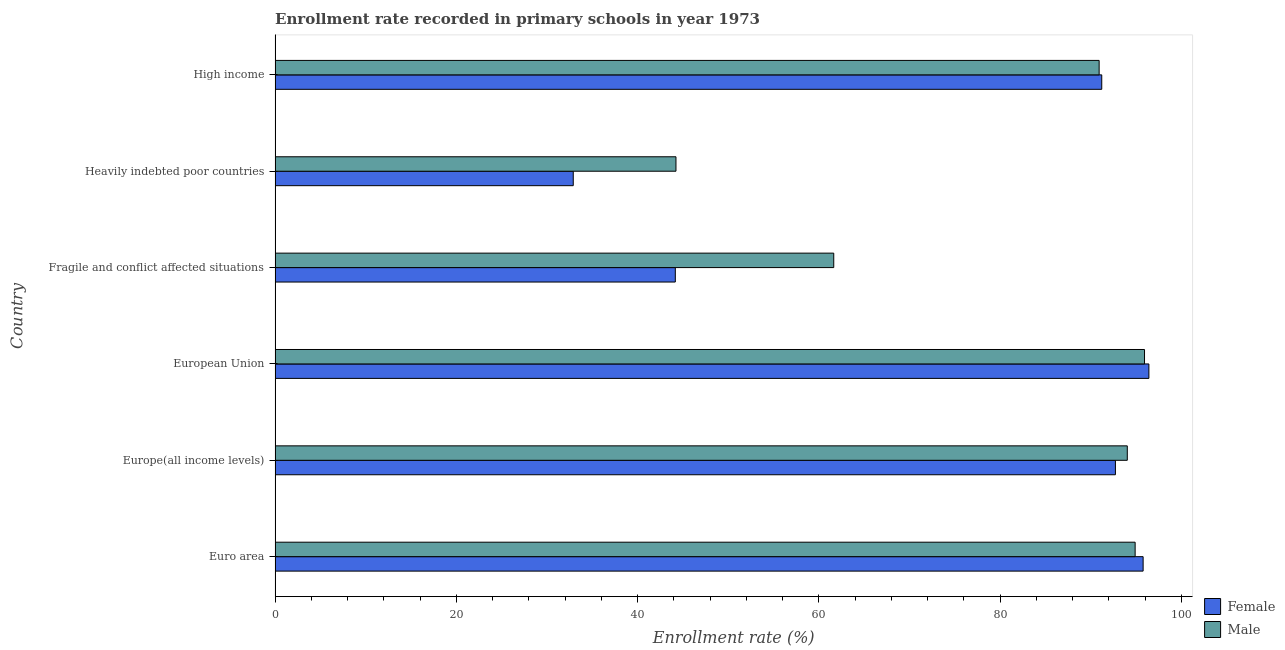How many different coloured bars are there?
Offer a terse response. 2. Are the number of bars on each tick of the Y-axis equal?
Your answer should be compact. Yes. How many bars are there on the 4th tick from the bottom?
Give a very brief answer. 2. In how many cases, is the number of bars for a given country not equal to the number of legend labels?
Your response must be concise. 0. What is the enrollment rate of female students in High income?
Your answer should be very brief. 91.22. Across all countries, what is the maximum enrollment rate of female students?
Give a very brief answer. 96.42. Across all countries, what is the minimum enrollment rate of male students?
Keep it short and to the point. 44.23. In which country was the enrollment rate of female students minimum?
Ensure brevity in your answer.  Heavily indebted poor countries. What is the total enrollment rate of female students in the graph?
Keep it short and to the point. 453.2. What is the difference between the enrollment rate of male students in Europe(all income levels) and that in European Union?
Your answer should be compact. -1.9. What is the difference between the enrollment rate of male students in Heavily indebted poor countries and the enrollment rate of female students in European Union?
Keep it short and to the point. -52.18. What is the average enrollment rate of male students per country?
Your response must be concise. 80.28. What is the difference between the enrollment rate of female students and enrollment rate of male students in European Union?
Your answer should be very brief. 0.48. In how many countries, is the enrollment rate of male students greater than 84 %?
Your answer should be very brief. 4. What is the ratio of the enrollment rate of female students in Euro area to that in Fragile and conflict affected situations?
Ensure brevity in your answer.  2.17. Is the enrollment rate of male students in Europe(all income levels) less than that in European Union?
Provide a succinct answer. Yes. What is the difference between the highest and the second highest enrollment rate of male students?
Your response must be concise. 1.03. What is the difference between the highest and the lowest enrollment rate of female students?
Your response must be concise. 63.52. Is the sum of the enrollment rate of male students in European Union and Fragile and conflict affected situations greater than the maximum enrollment rate of female students across all countries?
Your answer should be very brief. Yes. What does the 2nd bar from the top in Euro area represents?
Keep it short and to the point. Female. How many bars are there?
Make the answer very short. 12. Are all the bars in the graph horizontal?
Your answer should be very brief. Yes. What is the difference between two consecutive major ticks on the X-axis?
Provide a short and direct response. 20. Does the graph contain any zero values?
Ensure brevity in your answer.  No. Does the graph contain grids?
Make the answer very short. No. Where does the legend appear in the graph?
Provide a short and direct response. Bottom right. How are the legend labels stacked?
Provide a short and direct response. Vertical. What is the title of the graph?
Your response must be concise. Enrollment rate recorded in primary schools in year 1973. What is the label or title of the X-axis?
Your answer should be compact. Enrollment rate (%). What is the label or title of the Y-axis?
Offer a very short reply. Country. What is the Enrollment rate (%) of Female in Euro area?
Provide a short and direct response. 95.78. What is the Enrollment rate (%) in Male in Euro area?
Give a very brief answer. 94.9. What is the Enrollment rate (%) of Female in Europe(all income levels)?
Give a very brief answer. 92.72. What is the Enrollment rate (%) in Male in Europe(all income levels)?
Your answer should be compact. 94.03. What is the Enrollment rate (%) of Female in European Union?
Keep it short and to the point. 96.42. What is the Enrollment rate (%) of Male in European Union?
Offer a very short reply. 95.93. What is the Enrollment rate (%) in Female in Fragile and conflict affected situations?
Ensure brevity in your answer.  44.16. What is the Enrollment rate (%) in Male in Fragile and conflict affected situations?
Your response must be concise. 61.64. What is the Enrollment rate (%) of Female in Heavily indebted poor countries?
Ensure brevity in your answer.  32.9. What is the Enrollment rate (%) in Male in Heavily indebted poor countries?
Ensure brevity in your answer.  44.23. What is the Enrollment rate (%) in Female in High income?
Provide a succinct answer. 91.22. What is the Enrollment rate (%) of Male in High income?
Offer a very short reply. 90.93. Across all countries, what is the maximum Enrollment rate (%) in Female?
Offer a very short reply. 96.42. Across all countries, what is the maximum Enrollment rate (%) in Male?
Your answer should be very brief. 95.93. Across all countries, what is the minimum Enrollment rate (%) of Female?
Provide a succinct answer. 32.9. Across all countries, what is the minimum Enrollment rate (%) in Male?
Your answer should be compact. 44.23. What is the total Enrollment rate (%) in Female in the graph?
Keep it short and to the point. 453.2. What is the total Enrollment rate (%) of Male in the graph?
Provide a short and direct response. 481.67. What is the difference between the Enrollment rate (%) in Female in Euro area and that in Europe(all income levels)?
Your answer should be very brief. 3.06. What is the difference between the Enrollment rate (%) of Male in Euro area and that in Europe(all income levels)?
Your answer should be compact. 0.87. What is the difference between the Enrollment rate (%) of Female in Euro area and that in European Union?
Your response must be concise. -0.64. What is the difference between the Enrollment rate (%) of Male in Euro area and that in European Union?
Keep it short and to the point. -1.03. What is the difference between the Enrollment rate (%) in Female in Euro area and that in Fragile and conflict affected situations?
Your answer should be compact. 51.62. What is the difference between the Enrollment rate (%) of Male in Euro area and that in Fragile and conflict affected situations?
Provide a succinct answer. 33.25. What is the difference between the Enrollment rate (%) in Female in Euro area and that in Heavily indebted poor countries?
Your answer should be compact. 62.88. What is the difference between the Enrollment rate (%) of Male in Euro area and that in Heavily indebted poor countries?
Your answer should be compact. 50.66. What is the difference between the Enrollment rate (%) of Female in Euro area and that in High income?
Your response must be concise. 4.56. What is the difference between the Enrollment rate (%) in Male in Euro area and that in High income?
Provide a short and direct response. 3.97. What is the difference between the Enrollment rate (%) of Female in Europe(all income levels) and that in European Union?
Provide a short and direct response. -3.69. What is the difference between the Enrollment rate (%) in Male in Europe(all income levels) and that in European Union?
Provide a succinct answer. -1.9. What is the difference between the Enrollment rate (%) in Female in Europe(all income levels) and that in Fragile and conflict affected situations?
Offer a very short reply. 48.56. What is the difference between the Enrollment rate (%) in Male in Europe(all income levels) and that in Fragile and conflict affected situations?
Your answer should be compact. 32.39. What is the difference between the Enrollment rate (%) in Female in Europe(all income levels) and that in Heavily indebted poor countries?
Make the answer very short. 59.82. What is the difference between the Enrollment rate (%) of Male in Europe(all income levels) and that in Heavily indebted poor countries?
Keep it short and to the point. 49.8. What is the difference between the Enrollment rate (%) in Female in Europe(all income levels) and that in High income?
Ensure brevity in your answer.  1.51. What is the difference between the Enrollment rate (%) of Male in Europe(all income levels) and that in High income?
Give a very brief answer. 3.11. What is the difference between the Enrollment rate (%) in Female in European Union and that in Fragile and conflict affected situations?
Provide a succinct answer. 52.25. What is the difference between the Enrollment rate (%) of Male in European Union and that in Fragile and conflict affected situations?
Offer a terse response. 34.29. What is the difference between the Enrollment rate (%) in Female in European Union and that in Heavily indebted poor countries?
Give a very brief answer. 63.52. What is the difference between the Enrollment rate (%) of Male in European Union and that in Heavily indebted poor countries?
Ensure brevity in your answer.  51.7. What is the difference between the Enrollment rate (%) of Female in European Union and that in High income?
Your response must be concise. 5.2. What is the difference between the Enrollment rate (%) in Male in European Union and that in High income?
Keep it short and to the point. 5.01. What is the difference between the Enrollment rate (%) in Female in Fragile and conflict affected situations and that in Heavily indebted poor countries?
Make the answer very short. 11.26. What is the difference between the Enrollment rate (%) in Male in Fragile and conflict affected situations and that in Heavily indebted poor countries?
Provide a succinct answer. 17.41. What is the difference between the Enrollment rate (%) in Female in Fragile and conflict affected situations and that in High income?
Ensure brevity in your answer.  -47.05. What is the difference between the Enrollment rate (%) of Male in Fragile and conflict affected situations and that in High income?
Your answer should be compact. -29.28. What is the difference between the Enrollment rate (%) in Female in Heavily indebted poor countries and that in High income?
Provide a succinct answer. -58.31. What is the difference between the Enrollment rate (%) in Male in Heavily indebted poor countries and that in High income?
Ensure brevity in your answer.  -46.69. What is the difference between the Enrollment rate (%) of Female in Euro area and the Enrollment rate (%) of Male in Europe(all income levels)?
Keep it short and to the point. 1.75. What is the difference between the Enrollment rate (%) in Female in Euro area and the Enrollment rate (%) in Male in European Union?
Your response must be concise. -0.15. What is the difference between the Enrollment rate (%) of Female in Euro area and the Enrollment rate (%) of Male in Fragile and conflict affected situations?
Provide a short and direct response. 34.14. What is the difference between the Enrollment rate (%) of Female in Euro area and the Enrollment rate (%) of Male in Heavily indebted poor countries?
Ensure brevity in your answer.  51.55. What is the difference between the Enrollment rate (%) in Female in Euro area and the Enrollment rate (%) in Male in High income?
Make the answer very short. 4.85. What is the difference between the Enrollment rate (%) of Female in Europe(all income levels) and the Enrollment rate (%) of Male in European Union?
Keep it short and to the point. -3.21. What is the difference between the Enrollment rate (%) in Female in Europe(all income levels) and the Enrollment rate (%) in Male in Fragile and conflict affected situations?
Provide a short and direct response. 31.08. What is the difference between the Enrollment rate (%) in Female in Europe(all income levels) and the Enrollment rate (%) in Male in Heavily indebted poor countries?
Ensure brevity in your answer.  48.49. What is the difference between the Enrollment rate (%) in Female in Europe(all income levels) and the Enrollment rate (%) in Male in High income?
Your response must be concise. 1.8. What is the difference between the Enrollment rate (%) of Female in European Union and the Enrollment rate (%) of Male in Fragile and conflict affected situations?
Ensure brevity in your answer.  34.77. What is the difference between the Enrollment rate (%) of Female in European Union and the Enrollment rate (%) of Male in Heavily indebted poor countries?
Offer a terse response. 52.18. What is the difference between the Enrollment rate (%) of Female in European Union and the Enrollment rate (%) of Male in High income?
Offer a very short reply. 5.49. What is the difference between the Enrollment rate (%) in Female in Fragile and conflict affected situations and the Enrollment rate (%) in Male in Heavily indebted poor countries?
Offer a terse response. -0.07. What is the difference between the Enrollment rate (%) of Female in Fragile and conflict affected situations and the Enrollment rate (%) of Male in High income?
Give a very brief answer. -46.76. What is the difference between the Enrollment rate (%) of Female in Heavily indebted poor countries and the Enrollment rate (%) of Male in High income?
Give a very brief answer. -58.03. What is the average Enrollment rate (%) in Female per country?
Provide a succinct answer. 75.53. What is the average Enrollment rate (%) in Male per country?
Make the answer very short. 80.28. What is the difference between the Enrollment rate (%) of Female and Enrollment rate (%) of Male in Euro area?
Offer a very short reply. 0.88. What is the difference between the Enrollment rate (%) in Female and Enrollment rate (%) in Male in Europe(all income levels)?
Make the answer very short. -1.31. What is the difference between the Enrollment rate (%) in Female and Enrollment rate (%) in Male in European Union?
Your answer should be very brief. 0.48. What is the difference between the Enrollment rate (%) of Female and Enrollment rate (%) of Male in Fragile and conflict affected situations?
Offer a terse response. -17.48. What is the difference between the Enrollment rate (%) in Female and Enrollment rate (%) in Male in Heavily indebted poor countries?
Offer a terse response. -11.33. What is the difference between the Enrollment rate (%) of Female and Enrollment rate (%) of Male in High income?
Provide a short and direct response. 0.29. What is the ratio of the Enrollment rate (%) in Female in Euro area to that in Europe(all income levels)?
Make the answer very short. 1.03. What is the ratio of the Enrollment rate (%) of Male in Euro area to that in Europe(all income levels)?
Offer a terse response. 1.01. What is the ratio of the Enrollment rate (%) of Female in Euro area to that in Fragile and conflict affected situations?
Your answer should be compact. 2.17. What is the ratio of the Enrollment rate (%) in Male in Euro area to that in Fragile and conflict affected situations?
Your answer should be very brief. 1.54. What is the ratio of the Enrollment rate (%) in Female in Euro area to that in Heavily indebted poor countries?
Give a very brief answer. 2.91. What is the ratio of the Enrollment rate (%) of Male in Euro area to that in Heavily indebted poor countries?
Provide a succinct answer. 2.15. What is the ratio of the Enrollment rate (%) of Male in Euro area to that in High income?
Provide a succinct answer. 1.04. What is the ratio of the Enrollment rate (%) of Female in Europe(all income levels) to that in European Union?
Keep it short and to the point. 0.96. What is the ratio of the Enrollment rate (%) in Male in Europe(all income levels) to that in European Union?
Provide a short and direct response. 0.98. What is the ratio of the Enrollment rate (%) of Female in Europe(all income levels) to that in Fragile and conflict affected situations?
Give a very brief answer. 2.1. What is the ratio of the Enrollment rate (%) in Male in Europe(all income levels) to that in Fragile and conflict affected situations?
Give a very brief answer. 1.53. What is the ratio of the Enrollment rate (%) of Female in Europe(all income levels) to that in Heavily indebted poor countries?
Keep it short and to the point. 2.82. What is the ratio of the Enrollment rate (%) of Male in Europe(all income levels) to that in Heavily indebted poor countries?
Provide a succinct answer. 2.13. What is the ratio of the Enrollment rate (%) in Female in Europe(all income levels) to that in High income?
Your answer should be very brief. 1.02. What is the ratio of the Enrollment rate (%) of Male in Europe(all income levels) to that in High income?
Your response must be concise. 1.03. What is the ratio of the Enrollment rate (%) of Female in European Union to that in Fragile and conflict affected situations?
Give a very brief answer. 2.18. What is the ratio of the Enrollment rate (%) in Male in European Union to that in Fragile and conflict affected situations?
Ensure brevity in your answer.  1.56. What is the ratio of the Enrollment rate (%) of Female in European Union to that in Heavily indebted poor countries?
Your answer should be compact. 2.93. What is the ratio of the Enrollment rate (%) in Male in European Union to that in Heavily indebted poor countries?
Your response must be concise. 2.17. What is the ratio of the Enrollment rate (%) of Female in European Union to that in High income?
Provide a short and direct response. 1.06. What is the ratio of the Enrollment rate (%) of Male in European Union to that in High income?
Your answer should be compact. 1.06. What is the ratio of the Enrollment rate (%) in Female in Fragile and conflict affected situations to that in Heavily indebted poor countries?
Keep it short and to the point. 1.34. What is the ratio of the Enrollment rate (%) of Male in Fragile and conflict affected situations to that in Heavily indebted poor countries?
Provide a short and direct response. 1.39. What is the ratio of the Enrollment rate (%) of Female in Fragile and conflict affected situations to that in High income?
Provide a succinct answer. 0.48. What is the ratio of the Enrollment rate (%) in Male in Fragile and conflict affected situations to that in High income?
Give a very brief answer. 0.68. What is the ratio of the Enrollment rate (%) of Female in Heavily indebted poor countries to that in High income?
Provide a short and direct response. 0.36. What is the ratio of the Enrollment rate (%) of Male in Heavily indebted poor countries to that in High income?
Provide a short and direct response. 0.49. What is the difference between the highest and the second highest Enrollment rate (%) in Female?
Give a very brief answer. 0.64. What is the difference between the highest and the second highest Enrollment rate (%) in Male?
Provide a short and direct response. 1.03. What is the difference between the highest and the lowest Enrollment rate (%) in Female?
Offer a terse response. 63.52. What is the difference between the highest and the lowest Enrollment rate (%) of Male?
Offer a terse response. 51.7. 